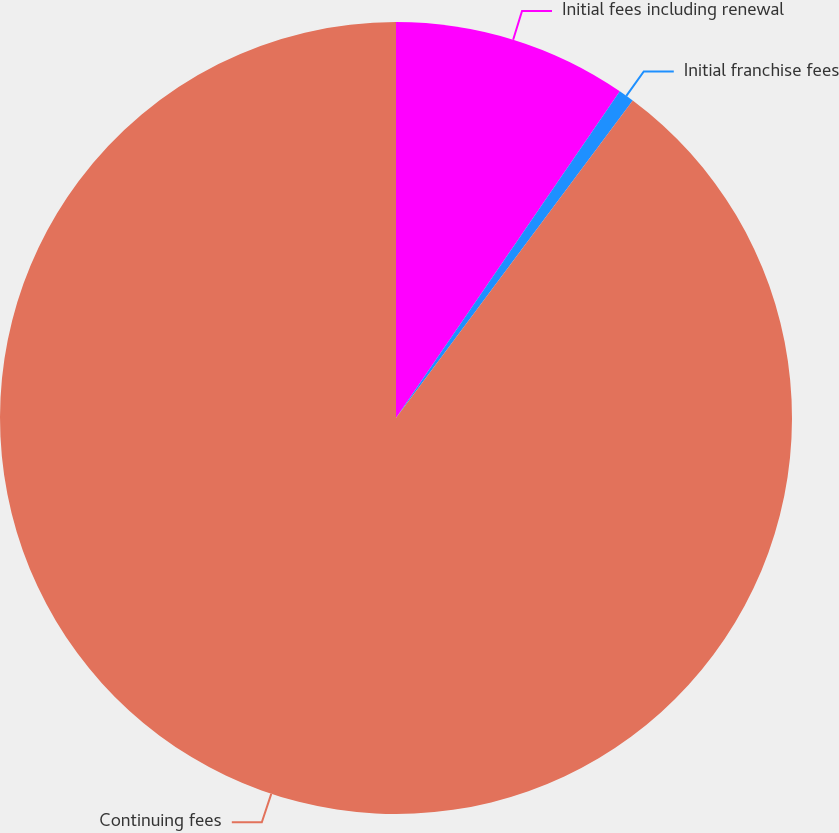<chart> <loc_0><loc_0><loc_500><loc_500><pie_chart><fcel>Initial fees including renewal<fcel>Initial franchise fees<fcel>Continuing fees<nl><fcel>9.56%<fcel>0.64%<fcel>89.8%<nl></chart> 